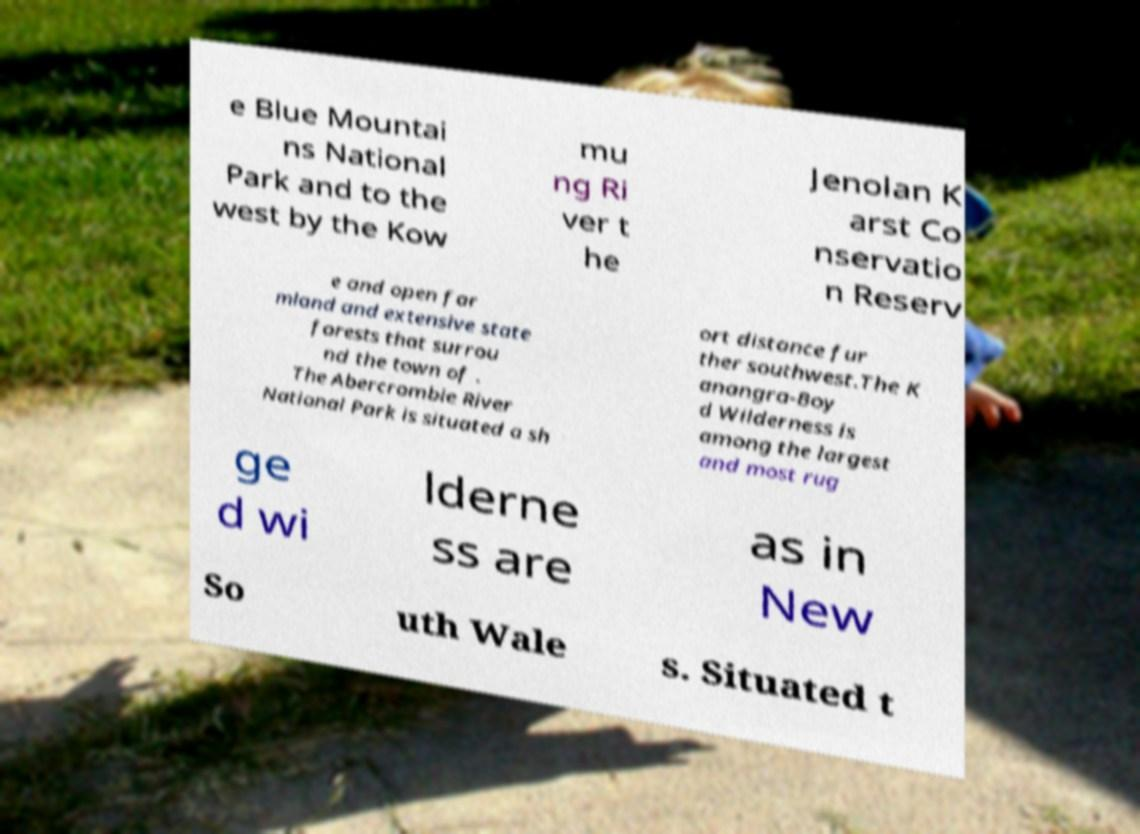Please read and relay the text visible in this image. What does it say? e Blue Mountai ns National Park and to the west by the Kow mu ng Ri ver t he Jenolan K arst Co nservatio n Reserv e and open far mland and extensive state forests that surrou nd the town of . The Abercrombie River National Park is situated a sh ort distance fur ther southwest.The K anangra-Boy d Wilderness is among the largest and most rug ge d wi lderne ss are as in New So uth Wale s. Situated t 